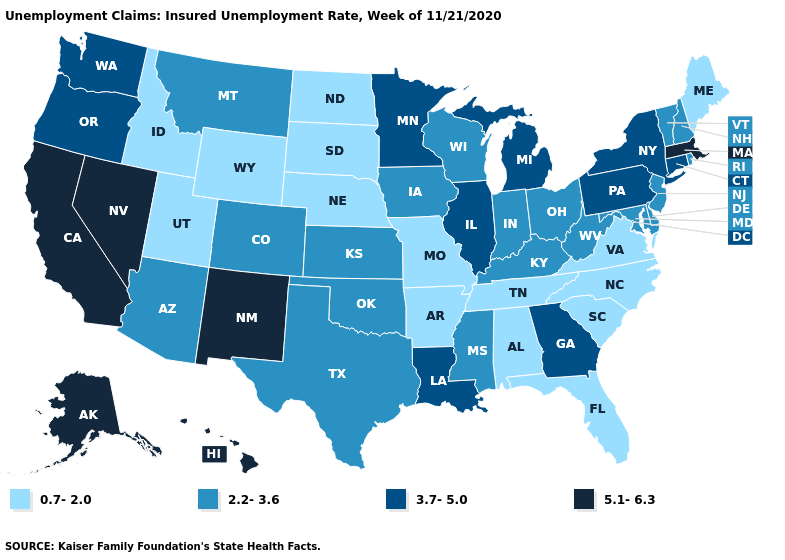Does Mississippi have the highest value in the USA?
Quick response, please. No. Name the states that have a value in the range 3.7-5.0?
Write a very short answer. Connecticut, Georgia, Illinois, Louisiana, Michigan, Minnesota, New York, Oregon, Pennsylvania, Washington. Does North Carolina have the lowest value in the USA?
Answer briefly. Yes. Does Florida have the lowest value in the South?
Short answer required. Yes. Which states have the lowest value in the West?
Answer briefly. Idaho, Utah, Wyoming. What is the lowest value in the USA?
Be succinct. 0.7-2.0. Name the states that have a value in the range 5.1-6.3?
Short answer required. Alaska, California, Hawaii, Massachusetts, Nevada, New Mexico. What is the value of Florida?
Keep it brief. 0.7-2.0. What is the value of North Dakota?
Concise answer only. 0.7-2.0. Among the states that border Pennsylvania , which have the highest value?
Concise answer only. New York. What is the lowest value in states that border Oregon?
Short answer required. 0.7-2.0. Which states have the lowest value in the MidWest?
Be succinct. Missouri, Nebraska, North Dakota, South Dakota. Among the states that border Maine , which have the lowest value?
Short answer required. New Hampshire. Name the states that have a value in the range 5.1-6.3?
Give a very brief answer. Alaska, California, Hawaii, Massachusetts, Nevada, New Mexico. Does Utah have the highest value in the West?
Be succinct. No. 